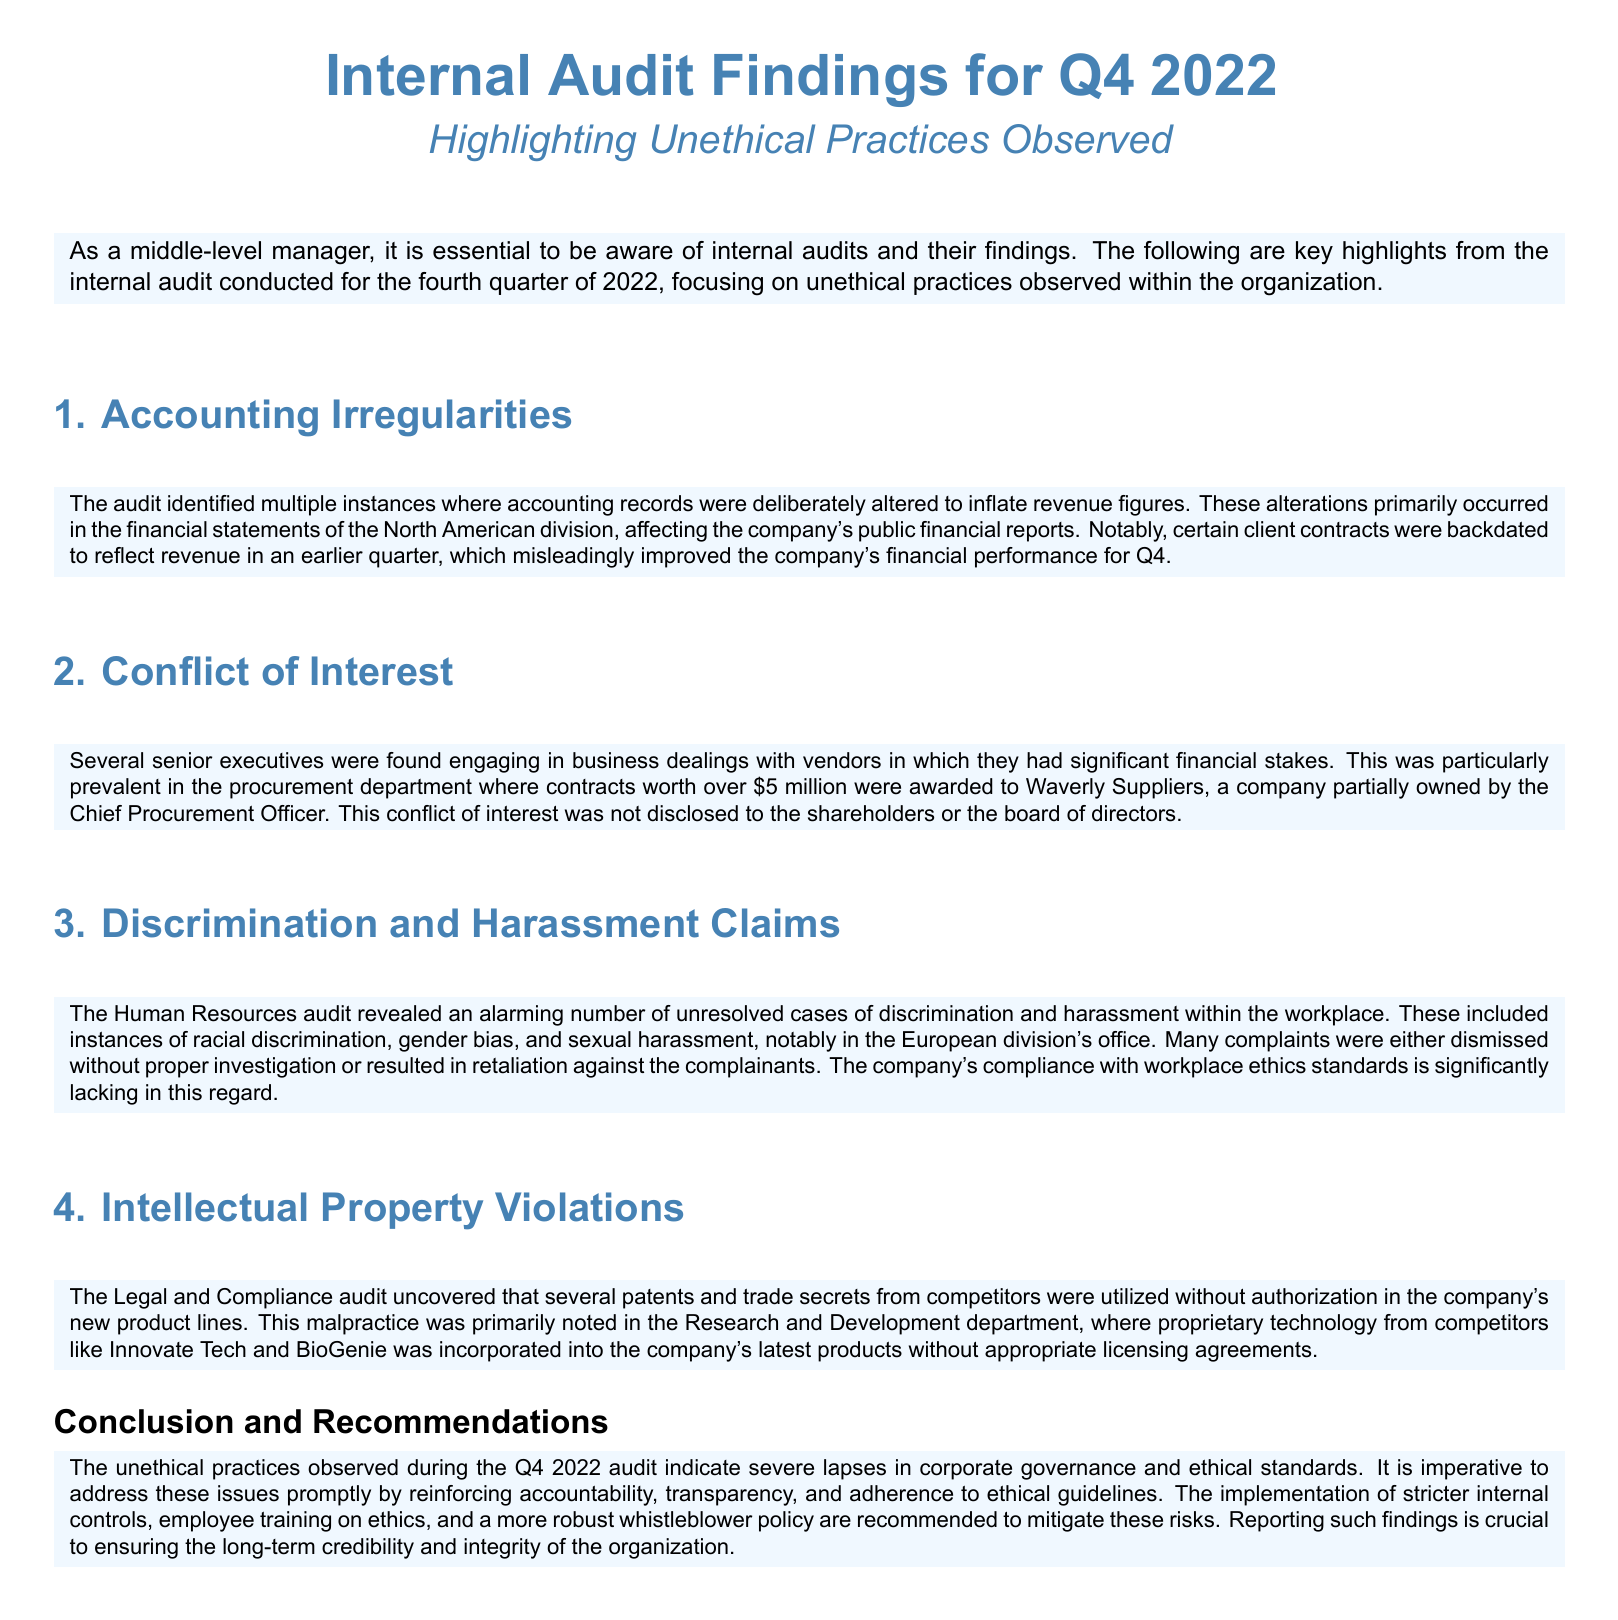What was one example of an accounting irregularity found? The document states that accounting records were deliberately altered to inflate revenue figures. Specific instances included backdating contracts to reflect revenue in an earlier quarter.
Answer: Backdating contracts How much was awarded to Waverly Suppliers? In the document, it notes that contracts worth over $5 million were awarded.
Answer: Over $5 million Which division had the most reported discrimination and harassment cases? The Human Resources audit revealed cases particularly prominent in the European division's office.
Answer: European division What unethical practice was uncovered in the Research and Development department? The audit uncovered that several patents and trade secrets from competitors were used without authorization.
Answer: Unauthorized use of patents and trade secrets What is a recommended action to address the issues found in the audit? The conclusion emphasizes the need for implementing stricter internal controls as a recommendation.
Answer: Stricter internal controls How did the company's executives manage their conflicts of interest? The document mentions that several senior executives engaged in business dealings with vendors where they had significant financial stakes without disclosure.
Answer: Non-disclosure of interests What did the audit reveal about the treatment of complainants in discrimination cases? Many complaints were dismissed without proper investigation or led to retaliation against the complainants.
Answer: Retaliation against complainants What type of violations were noted regarding workplace ethics? The document states that the company's compliance with workplace ethics standards is lacking due to numerous unresolved cases of discrimination and harassment.
Answer: Lack of compliance with ethics standards 